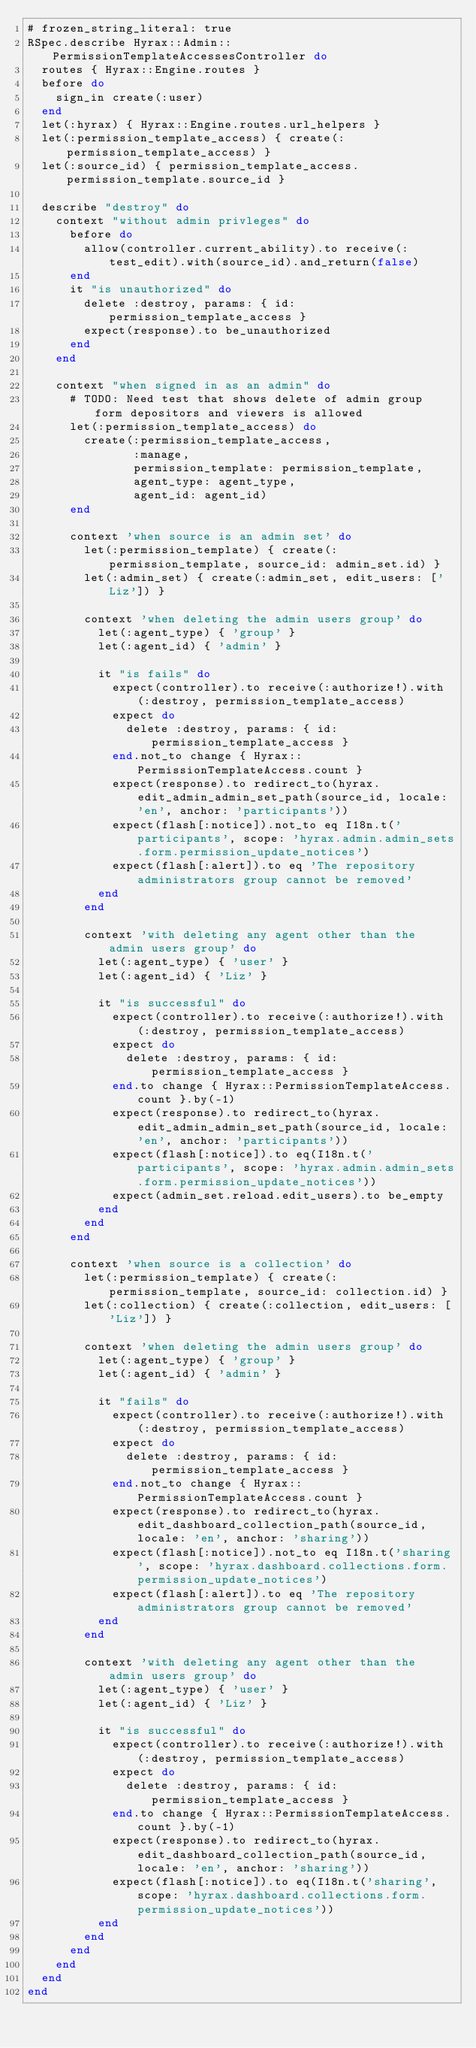<code> <loc_0><loc_0><loc_500><loc_500><_Ruby_># frozen_string_literal: true
RSpec.describe Hyrax::Admin::PermissionTemplateAccessesController do
  routes { Hyrax::Engine.routes }
  before do
    sign_in create(:user)
  end
  let(:hyrax) { Hyrax::Engine.routes.url_helpers }
  let(:permission_template_access) { create(:permission_template_access) }
  let(:source_id) { permission_template_access.permission_template.source_id }

  describe "destroy" do
    context "without admin privleges" do
      before do
        allow(controller.current_ability).to receive(:test_edit).with(source_id).and_return(false)
      end
      it "is unauthorized" do
        delete :destroy, params: { id: permission_template_access }
        expect(response).to be_unauthorized
      end
    end

    context "when signed in as an admin" do
      # TODO: Need test that shows delete of admin group form depositors and viewers is allowed
      let(:permission_template_access) do
        create(:permission_template_access,
               :manage,
               permission_template: permission_template,
               agent_type: agent_type,
               agent_id: agent_id)
      end

      context 'when source is an admin set' do
        let(:permission_template) { create(:permission_template, source_id: admin_set.id) }
        let(:admin_set) { create(:admin_set, edit_users: ['Liz']) }

        context 'when deleting the admin users group' do
          let(:agent_type) { 'group' }
          let(:agent_id) { 'admin' }

          it "is fails" do
            expect(controller).to receive(:authorize!).with(:destroy, permission_template_access)
            expect do
              delete :destroy, params: { id: permission_template_access }
            end.not_to change { Hyrax::PermissionTemplateAccess.count }
            expect(response).to redirect_to(hyrax.edit_admin_admin_set_path(source_id, locale: 'en', anchor: 'participants'))
            expect(flash[:notice]).not_to eq I18n.t('participants', scope: 'hyrax.admin.admin_sets.form.permission_update_notices')
            expect(flash[:alert]).to eq 'The repository administrators group cannot be removed'
          end
        end

        context 'with deleting any agent other than the admin users group' do
          let(:agent_type) { 'user' }
          let(:agent_id) { 'Liz' }

          it "is successful" do
            expect(controller).to receive(:authorize!).with(:destroy, permission_template_access)
            expect do
              delete :destroy, params: { id: permission_template_access }
            end.to change { Hyrax::PermissionTemplateAccess.count }.by(-1)
            expect(response).to redirect_to(hyrax.edit_admin_admin_set_path(source_id, locale: 'en', anchor: 'participants'))
            expect(flash[:notice]).to eq(I18n.t('participants', scope: 'hyrax.admin.admin_sets.form.permission_update_notices'))
            expect(admin_set.reload.edit_users).to be_empty
          end
        end
      end

      context 'when source is a collection' do
        let(:permission_template) { create(:permission_template, source_id: collection.id) }
        let(:collection) { create(:collection, edit_users: ['Liz']) }

        context 'when deleting the admin users group' do
          let(:agent_type) { 'group' }
          let(:agent_id) { 'admin' }

          it "fails" do
            expect(controller).to receive(:authorize!).with(:destroy, permission_template_access)
            expect do
              delete :destroy, params: { id: permission_template_access }
            end.not_to change { Hyrax::PermissionTemplateAccess.count }
            expect(response).to redirect_to(hyrax.edit_dashboard_collection_path(source_id, locale: 'en', anchor: 'sharing'))
            expect(flash[:notice]).not_to eq I18n.t('sharing', scope: 'hyrax.dashboard.collections.form.permission_update_notices')
            expect(flash[:alert]).to eq 'The repository administrators group cannot be removed'
          end
        end

        context 'with deleting any agent other than the admin users group' do
          let(:agent_type) { 'user' }
          let(:agent_id) { 'Liz' }

          it "is successful" do
            expect(controller).to receive(:authorize!).with(:destroy, permission_template_access)
            expect do
              delete :destroy, params: { id: permission_template_access }
            end.to change { Hyrax::PermissionTemplateAccess.count }.by(-1)
            expect(response).to redirect_to(hyrax.edit_dashboard_collection_path(source_id, locale: 'en', anchor: 'sharing'))
            expect(flash[:notice]).to eq(I18n.t('sharing', scope: 'hyrax.dashboard.collections.form.permission_update_notices'))
          end
        end
      end
    end
  end
end
</code> 